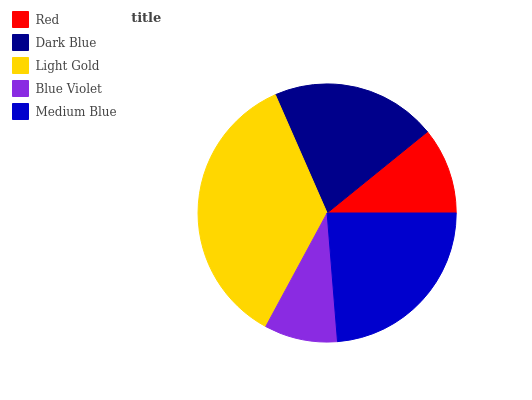Is Blue Violet the minimum?
Answer yes or no. Yes. Is Light Gold the maximum?
Answer yes or no. Yes. Is Dark Blue the minimum?
Answer yes or no. No. Is Dark Blue the maximum?
Answer yes or no. No. Is Dark Blue greater than Red?
Answer yes or no. Yes. Is Red less than Dark Blue?
Answer yes or no. Yes. Is Red greater than Dark Blue?
Answer yes or no. No. Is Dark Blue less than Red?
Answer yes or no. No. Is Dark Blue the high median?
Answer yes or no. Yes. Is Dark Blue the low median?
Answer yes or no. Yes. Is Medium Blue the high median?
Answer yes or no. No. Is Red the low median?
Answer yes or no. No. 